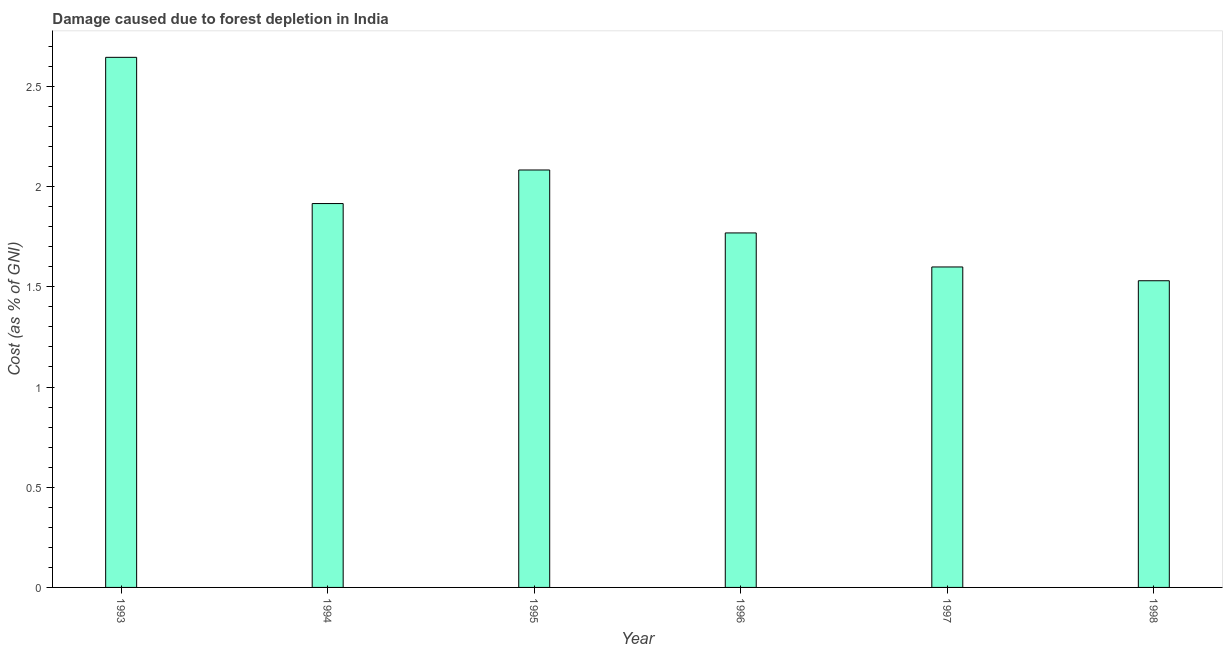Does the graph contain any zero values?
Provide a succinct answer. No. What is the title of the graph?
Provide a succinct answer. Damage caused due to forest depletion in India. What is the label or title of the Y-axis?
Keep it short and to the point. Cost (as % of GNI). What is the damage caused due to forest depletion in 1996?
Make the answer very short. 1.77. Across all years, what is the maximum damage caused due to forest depletion?
Your answer should be compact. 2.65. Across all years, what is the minimum damage caused due to forest depletion?
Your response must be concise. 1.53. In which year was the damage caused due to forest depletion minimum?
Ensure brevity in your answer.  1998. What is the sum of the damage caused due to forest depletion?
Offer a very short reply. 11.54. What is the difference between the damage caused due to forest depletion in 1996 and 1998?
Your answer should be compact. 0.24. What is the average damage caused due to forest depletion per year?
Your answer should be very brief. 1.92. What is the median damage caused due to forest depletion?
Your answer should be very brief. 1.84. In how many years, is the damage caused due to forest depletion greater than 0.7 %?
Your answer should be very brief. 6. What is the ratio of the damage caused due to forest depletion in 1996 to that in 1997?
Provide a succinct answer. 1.11. Is the damage caused due to forest depletion in 1993 less than that in 1994?
Offer a terse response. No. What is the difference between the highest and the second highest damage caused due to forest depletion?
Offer a terse response. 0.56. What is the difference between the highest and the lowest damage caused due to forest depletion?
Your answer should be very brief. 1.11. How many bars are there?
Provide a short and direct response. 6. What is the difference between two consecutive major ticks on the Y-axis?
Offer a terse response. 0.5. What is the Cost (as % of GNI) of 1993?
Offer a very short reply. 2.65. What is the Cost (as % of GNI) of 1994?
Provide a short and direct response. 1.92. What is the Cost (as % of GNI) in 1995?
Ensure brevity in your answer.  2.08. What is the Cost (as % of GNI) in 1996?
Give a very brief answer. 1.77. What is the Cost (as % of GNI) of 1997?
Ensure brevity in your answer.  1.6. What is the Cost (as % of GNI) in 1998?
Your answer should be very brief. 1.53. What is the difference between the Cost (as % of GNI) in 1993 and 1994?
Provide a short and direct response. 0.73. What is the difference between the Cost (as % of GNI) in 1993 and 1995?
Your response must be concise. 0.56. What is the difference between the Cost (as % of GNI) in 1993 and 1996?
Give a very brief answer. 0.88. What is the difference between the Cost (as % of GNI) in 1993 and 1997?
Offer a terse response. 1.05. What is the difference between the Cost (as % of GNI) in 1993 and 1998?
Give a very brief answer. 1.11. What is the difference between the Cost (as % of GNI) in 1994 and 1995?
Offer a very short reply. -0.17. What is the difference between the Cost (as % of GNI) in 1994 and 1996?
Provide a succinct answer. 0.15. What is the difference between the Cost (as % of GNI) in 1994 and 1997?
Give a very brief answer. 0.32. What is the difference between the Cost (as % of GNI) in 1994 and 1998?
Offer a terse response. 0.39. What is the difference between the Cost (as % of GNI) in 1995 and 1996?
Your response must be concise. 0.31. What is the difference between the Cost (as % of GNI) in 1995 and 1997?
Offer a terse response. 0.48. What is the difference between the Cost (as % of GNI) in 1995 and 1998?
Ensure brevity in your answer.  0.55. What is the difference between the Cost (as % of GNI) in 1996 and 1997?
Provide a short and direct response. 0.17. What is the difference between the Cost (as % of GNI) in 1996 and 1998?
Your answer should be compact. 0.24. What is the difference between the Cost (as % of GNI) in 1997 and 1998?
Offer a terse response. 0.07. What is the ratio of the Cost (as % of GNI) in 1993 to that in 1994?
Provide a succinct answer. 1.38. What is the ratio of the Cost (as % of GNI) in 1993 to that in 1995?
Give a very brief answer. 1.27. What is the ratio of the Cost (as % of GNI) in 1993 to that in 1996?
Your answer should be very brief. 1.5. What is the ratio of the Cost (as % of GNI) in 1993 to that in 1997?
Your answer should be very brief. 1.65. What is the ratio of the Cost (as % of GNI) in 1993 to that in 1998?
Ensure brevity in your answer.  1.73. What is the ratio of the Cost (as % of GNI) in 1994 to that in 1995?
Provide a short and direct response. 0.92. What is the ratio of the Cost (as % of GNI) in 1994 to that in 1996?
Ensure brevity in your answer.  1.08. What is the ratio of the Cost (as % of GNI) in 1994 to that in 1997?
Provide a succinct answer. 1.2. What is the ratio of the Cost (as % of GNI) in 1994 to that in 1998?
Make the answer very short. 1.25. What is the ratio of the Cost (as % of GNI) in 1995 to that in 1996?
Offer a very short reply. 1.18. What is the ratio of the Cost (as % of GNI) in 1995 to that in 1997?
Offer a terse response. 1.3. What is the ratio of the Cost (as % of GNI) in 1995 to that in 1998?
Offer a very short reply. 1.36. What is the ratio of the Cost (as % of GNI) in 1996 to that in 1997?
Give a very brief answer. 1.11. What is the ratio of the Cost (as % of GNI) in 1996 to that in 1998?
Offer a very short reply. 1.16. What is the ratio of the Cost (as % of GNI) in 1997 to that in 1998?
Keep it short and to the point. 1.04. 